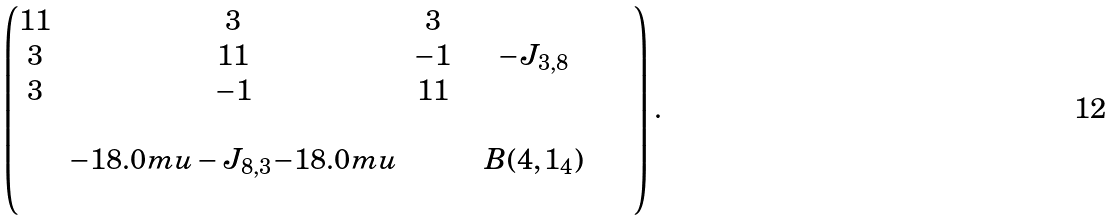<formula> <loc_0><loc_0><loc_500><loc_500>\begin{pmatrix} 1 1 & 3 & 3 & & & \\ 3 & 1 1 & - 1 & & - J _ { 3 , 8 } & \\ 3 & - 1 & 1 1 & & & \\ & & & & & \\ & { - 1 8 . 0 m u } - J _ { 8 , 3 } { - 1 8 . 0 m u } & & & B ( 4 , 1 _ { 4 } ) & \\ & & & & & & & \\ \end{pmatrix} .</formula> 